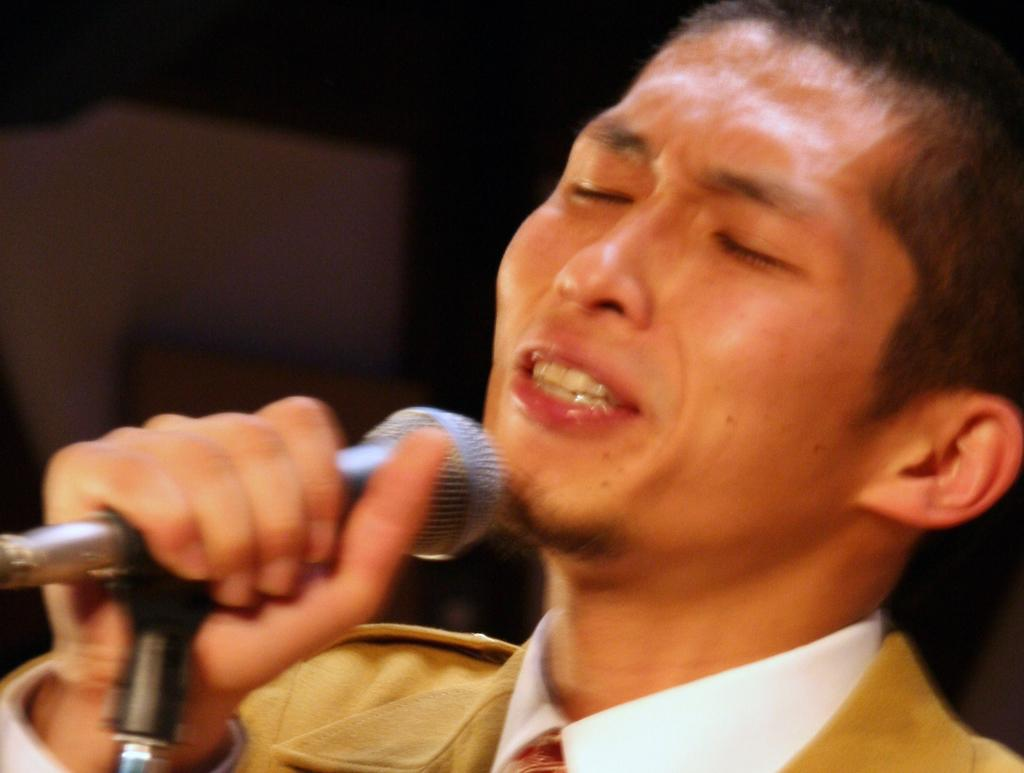Who is the main subject in the foreground of the image? There is a man in the foreground of the image. What is the man wearing? The man is wearing a cream coat. What is the man holding in his hand? The man is holding a mic. How is the mic positioned in the image? The mic is on a stand. What can be observed about the background of the image? The background of the image is dark. What type of space vessel can be seen in the background of the image? There is no space vessel present in the image; the background is dark. 